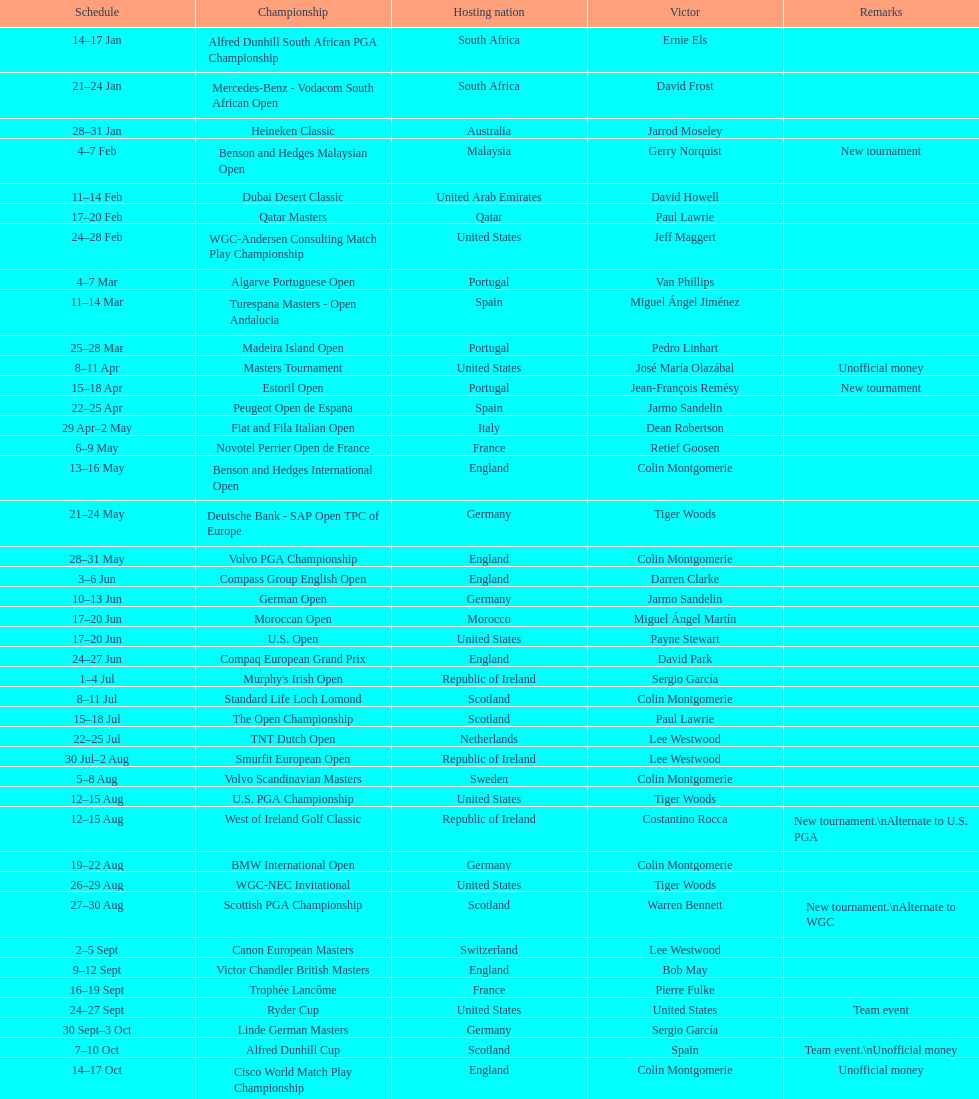Help me parse the entirety of this table. {'header': ['Schedule', 'Championship', 'Hosting nation', 'Victor', 'Remarks'], 'rows': [['14–17\xa0Jan', 'Alfred Dunhill South African PGA Championship', 'South Africa', 'Ernie Els', ''], ['21–24\xa0Jan', 'Mercedes-Benz - Vodacom South African Open', 'South Africa', 'David Frost', ''], ['28–31\xa0Jan', 'Heineken Classic', 'Australia', 'Jarrod Moseley', ''], ['4–7\xa0Feb', 'Benson and Hedges Malaysian Open', 'Malaysia', 'Gerry Norquist', 'New tournament'], ['11–14\xa0Feb', 'Dubai Desert Classic', 'United Arab Emirates', 'David Howell', ''], ['17–20\xa0Feb', 'Qatar Masters', 'Qatar', 'Paul Lawrie', ''], ['24–28\xa0Feb', 'WGC-Andersen Consulting Match Play Championship', 'United States', 'Jeff Maggert', ''], ['4–7\xa0Mar', 'Algarve Portuguese Open', 'Portugal', 'Van Phillips', ''], ['11–14\xa0Mar', 'Turespana Masters - Open Andalucia', 'Spain', 'Miguel Ángel Jiménez', ''], ['25–28\xa0Mar', 'Madeira Island Open', 'Portugal', 'Pedro Linhart', ''], ['8–11\xa0Apr', 'Masters Tournament', 'United States', 'José María Olazábal', 'Unofficial money'], ['15–18\xa0Apr', 'Estoril Open', 'Portugal', 'Jean-François Remésy', 'New tournament'], ['22–25\xa0Apr', 'Peugeot Open de Espana', 'Spain', 'Jarmo Sandelin', ''], ['29\xa0Apr–2\xa0May', 'Fiat and Fila Italian Open', 'Italy', 'Dean Robertson', ''], ['6–9\xa0May', 'Novotel Perrier Open de France', 'France', 'Retief Goosen', ''], ['13–16\xa0May', 'Benson and Hedges International Open', 'England', 'Colin Montgomerie', ''], ['21–24\xa0May', 'Deutsche Bank - SAP Open TPC of Europe', 'Germany', 'Tiger Woods', ''], ['28–31\xa0May', 'Volvo PGA Championship', 'England', 'Colin Montgomerie', ''], ['3–6\xa0Jun', 'Compass Group English Open', 'England', 'Darren Clarke', ''], ['10–13\xa0Jun', 'German Open', 'Germany', 'Jarmo Sandelin', ''], ['17–20\xa0Jun', 'Moroccan Open', 'Morocco', 'Miguel Ángel Martín', ''], ['17–20\xa0Jun', 'U.S. Open', 'United States', 'Payne Stewart', ''], ['24–27\xa0Jun', 'Compaq European Grand Prix', 'England', 'David Park', ''], ['1–4\xa0Jul', "Murphy's Irish Open", 'Republic of Ireland', 'Sergio García', ''], ['8–11\xa0Jul', 'Standard Life Loch Lomond', 'Scotland', 'Colin Montgomerie', ''], ['15–18\xa0Jul', 'The Open Championship', 'Scotland', 'Paul Lawrie', ''], ['22–25\xa0Jul', 'TNT Dutch Open', 'Netherlands', 'Lee Westwood', ''], ['30\xa0Jul–2\xa0Aug', 'Smurfit European Open', 'Republic of Ireland', 'Lee Westwood', ''], ['5–8\xa0Aug', 'Volvo Scandinavian Masters', 'Sweden', 'Colin Montgomerie', ''], ['12–15\xa0Aug', 'U.S. PGA Championship', 'United States', 'Tiger Woods', ''], ['12–15\xa0Aug', 'West of Ireland Golf Classic', 'Republic of Ireland', 'Costantino Rocca', 'New tournament.\\nAlternate to U.S. PGA'], ['19–22\xa0Aug', 'BMW International Open', 'Germany', 'Colin Montgomerie', ''], ['26–29\xa0Aug', 'WGC-NEC Invitational', 'United States', 'Tiger Woods', ''], ['27–30\xa0Aug', 'Scottish PGA Championship', 'Scotland', 'Warren Bennett', 'New tournament.\\nAlternate to WGC'], ['2–5\xa0Sept', 'Canon European Masters', 'Switzerland', 'Lee Westwood', ''], ['9–12\xa0Sept', 'Victor Chandler British Masters', 'England', 'Bob May', ''], ['16–19\xa0Sept', 'Trophée Lancôme', 'France', 'Pierre Fulke', ''], ['24–27\xa0Sept', 'Ryder Cup', 'United States', 'United States', 'Team event'], ['30\xa0Sept–3\xa0Oct', 'Linde German Masters', 'Germany', 'Sergio García', ''], ['7–10\xa0Oct', 'Alfred Dunhill Cup', 'Scotland', 'Spain', 'Team event.\\nUnofficial money'], ['14–17\xa0Oct', 'Cisco World Match Play Championship', 'England', 'Colin Montgomerie', 'Unofficial money'], ['14–17\xa0Oct', 'Sarazen World Open', 'Spain', 'Thomas Bjørn', 'New tournament'], ['21–24\xa0Oct', 'Belgacom Open', 'Belgium', 'Robert Karlsson', ''], ['28–31\xa0Oct', 'Volvo Masters', 'Spain', 'Miguel Ángel Jiménez', ''], ['4–7\xa0Nov', 'WGC-American Express Championship', 'Spain', 'Tiger Woods', ''], ['18–21\xa0Nov', 'World Cup of Golf', 'Malaysia', 'United States', 'Team event.\\nUnofficial money']]} Which winner won more tournaments, jeff maggert or tiger woods? Tiger Woods. 